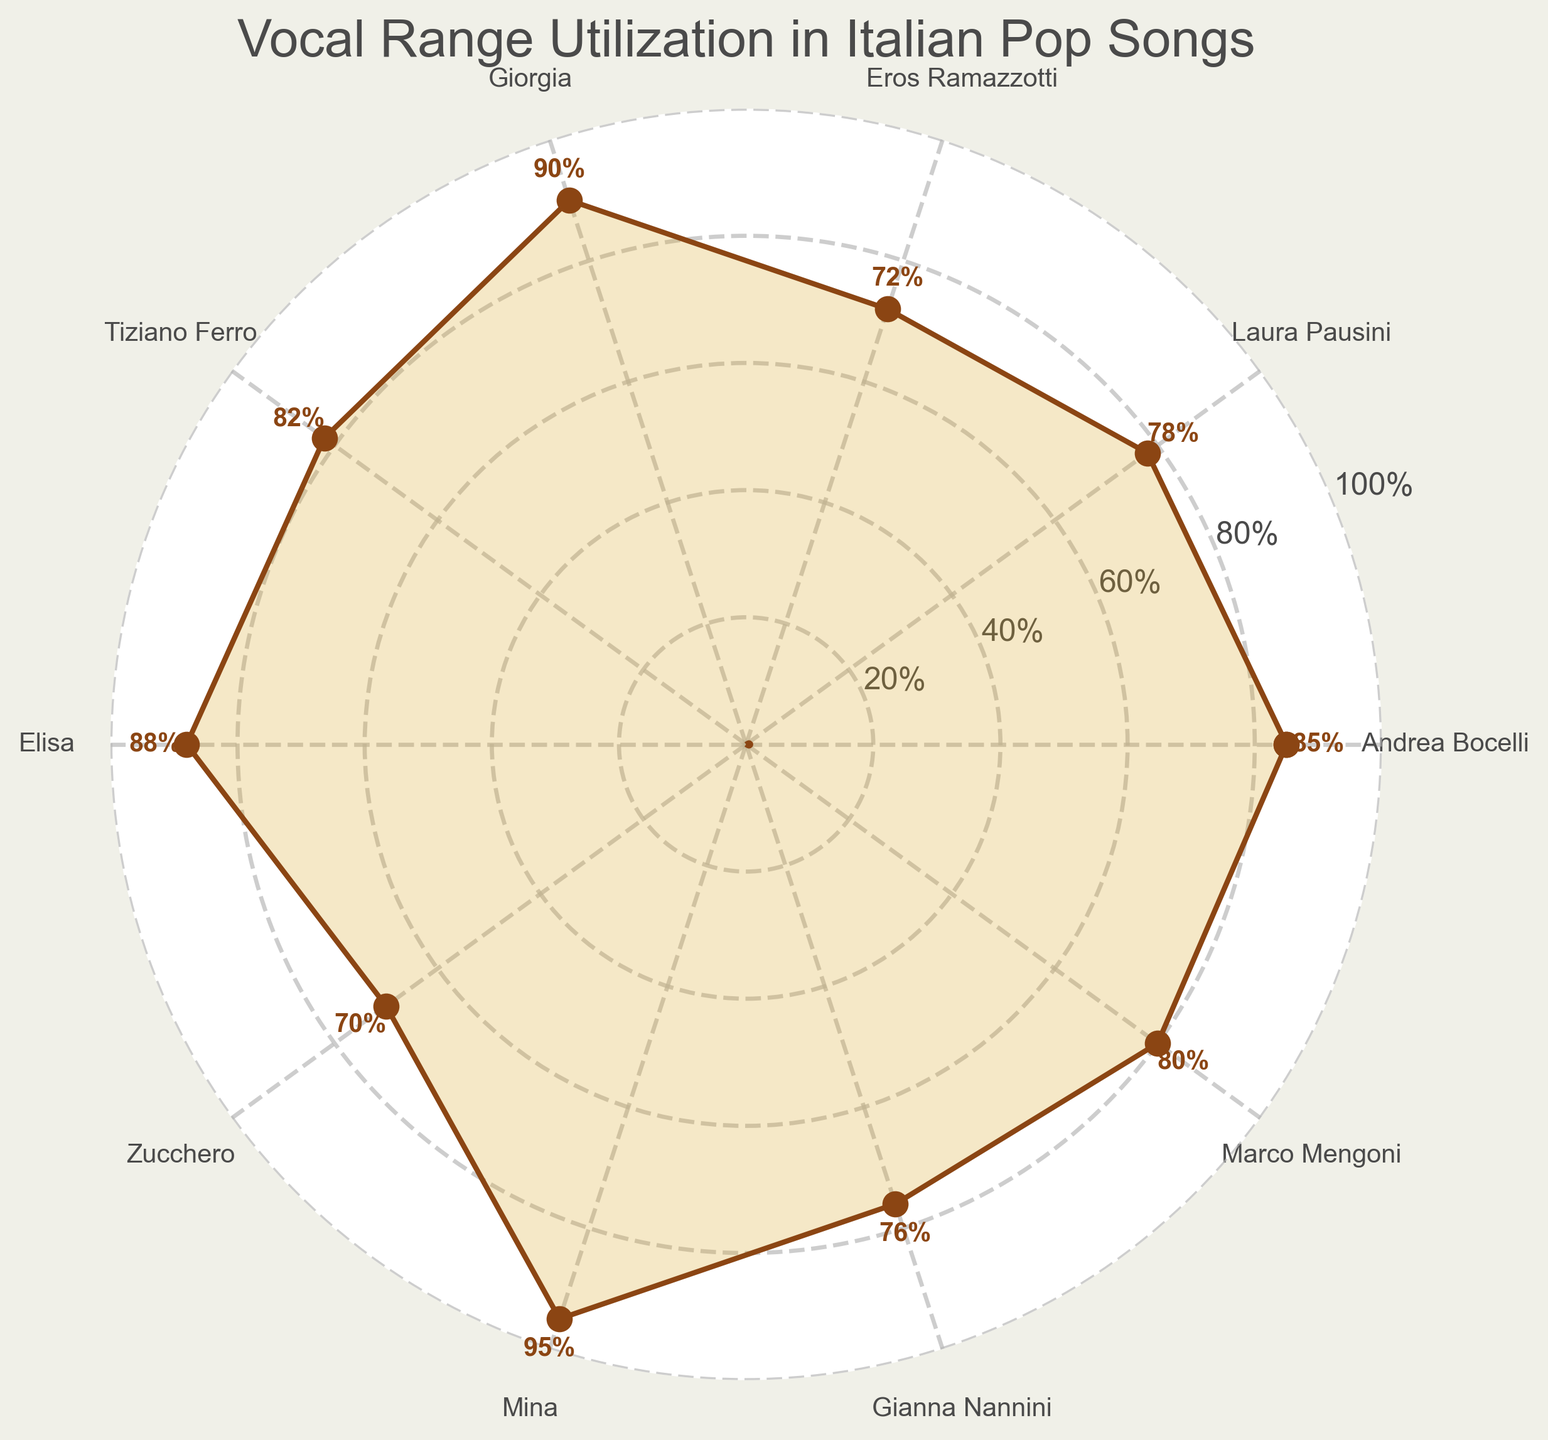What's the title of the figure? The title of the figure is located at the top and reads "Vocal Range Utilization in Italian Pop Songs".
Answer: Vocal Range Utilization in Italian Pop Songs Which singer has the highest vocal range utilization percentage? The vocal range utilization percentage is denoted by the values on the plot. The singer with the highest percentage is Mina, with 95%.
Answer: Mina How many singers have a vocal range utilization percentage above 80%? By examining the values, there are 7 singers (Andrea Bocelli, Laura Pausini, Giorgia, Tiziano Ferro, Elisa, Mina, and Marco Mengoni) with a percentage above 80%.
Answer: 7 What's the vocal range utilization difference between Andrea Bocelli and Zucchero? Andrea Bocelli has a utilization of 85% and Zucchero has 70%. The difference is calculated as 85% - 70% = 15%.
Answer: 15% Which singer has the lowest vocal range utilization percentage? The singer with the lowest percentage is Zucchero with 70%.
Answer: Zucchero What's the median vocal range utilization percentage of the singers? First, order the percentages: 70, 72, 76, 78, 80, 82, 85, 88, 90, 95. The middle values are 80 and 82, their average is (80 + 82) / 2 = 81.
Answer: 81 Are there more singers with a utilization percentage above 85% or below 80%? There are 4 singers above 85% (Giorgia, Elisa, Mina, Andrea Bocelli) and 4 singers below 80% (Eros Ramazzotti, Zucchero, Gianna Nannini, Laura Pausini). The numbers are equal.
Answer: Equal Which singers have a vocal range utilization percentage between 70% and 80%? By examining the values, the singers in this range are Eros Ramazzotti (72%), Zucchero (70%), Gianna Nannini (76%), and Laura Pausini (78%).
Answer: Eros Ramazzotti, Zucchero, Gianna Nannini, Laura Pausini How similar are the vocal range utilizations of Tiziano Ferro and Marco Mengoni? Tiziano Ferro has a 82% utilization, while Marco Mengoni has 80%. The difference is 82% - 80% = 2%, indicating they are very similar.
Answer: Very Similar 